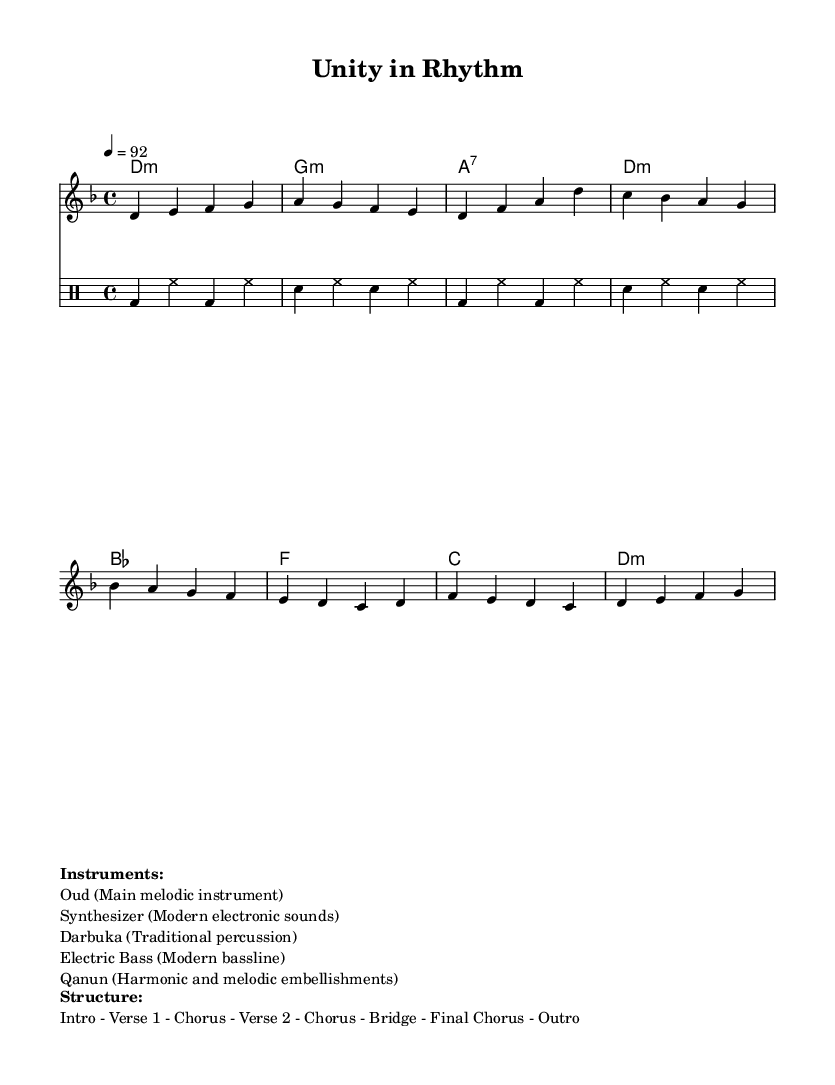What is the key signature of this music? The key signature is D minor, which has one flat (B flat). It can be identified in the score by looking for the signature at the beginning of the staff.
Answer: D minor What is the time signature of the piece? The time signature is 4/4, which indicates there are four beats in each measure, and each quarter note gets one beat. This is noted at the beginning of the score.
Answer: 4/4 What is the tempo marking of the piece? The tempo marking is 92 beats per minute, indicated as "4 = 92" in the tempo directive. This means there are 92 quarter-note beats in a minute.
Answer: 92 How many instruments are listed for this piece? There are five instruments listed in the score: Oud, Synthesizer, Darbuka, Electric Bass, and Qanun. Counting them in the provided instrumentation section gives the total.
Answer: Five What is the structure of the piece? The structure of the piece includes an Intro, Verse 1, Chorus, Verse 2, Chorus, Bridge, Final Chorus, and Outro. This can be understood from the breakdown in the structure section of the score.
Answer: Intro - Verse 1 - Chorus - Verse 2 - Chorus - Bridge - Final Chorus - Outro Which percussion instrument is used in this piece? The percussion instrument used is the Darbuka, as listed in the instruments section. It is a traditional Middle Eastern percussion instrument that complements the rhythmic elements of the music.
Answer: Darbuka What is the primary melodic instrument in this composition? The primary melodic instrument is the Oud, which typically serves as the main source of melody in traditional Middle Eastern music. This is clearly stated in the instruments section of the score.
Answer: Oud 